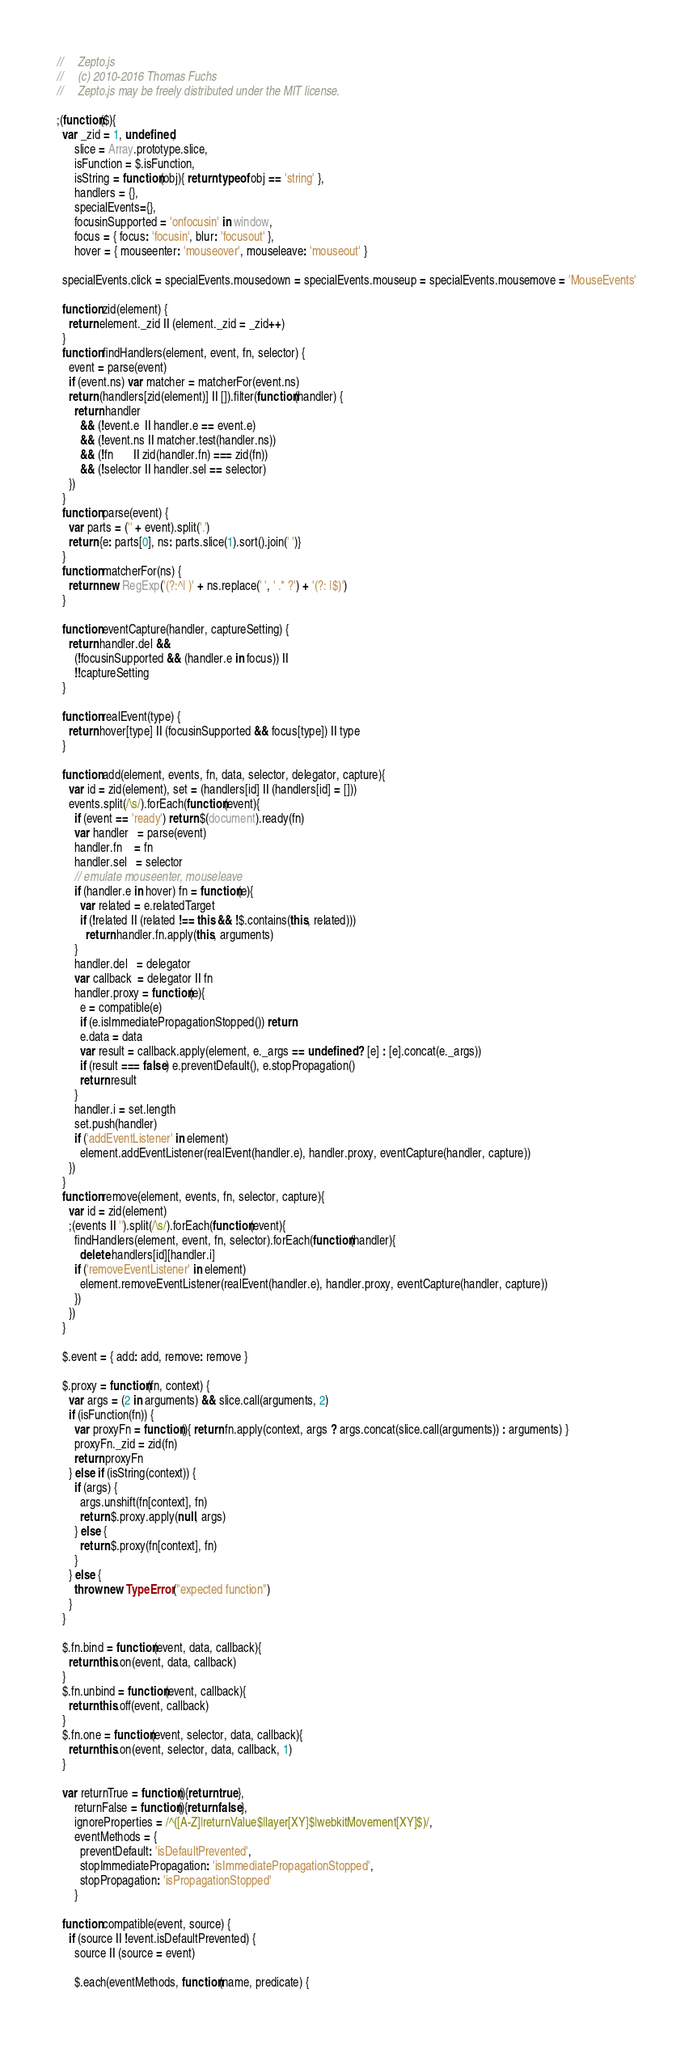Convert code to text. <code><loc_0><loc_0><loc_500><loc_500><_JavaScript_>//     Zepto.js
//     (c) 2010-2016 Thomas Fuchs
//     Zepto.js may be freely distributed under the MIT license.

;(function($){
  var _zid = 1, undefined,
      slice = Array.prototype.slice,
      isFunction = $.isFunction,
      isString = function(obj){ return typeof obj == 'string' },
      handlers = {},
      specialEvents={},
      focusinSupported = 'onfocusin' in window,
      focus = { focus: 'focusin', blur: 'focusout' },
      hover = { mouseenter: 'mouseover', mouseleave: 'mouseout' }

  specialEvents.click = specialEvents.mousedown = specialEvents.mouseup = specialEvents.mousemove = 'MouseEvents'

  function zid(element) {
    return element._zid || (element._zid = _zid++)
  }
  function findHandlers(element, event, fn, selector) {
    event = parse(event)
    if (event.ns) var matcher = matcherFor(event.ns)
    return (handlers[zid(element)] || []).filter(function(handler) {
      return handler
        && (!event.e  || handler.e == event.e)
        && (!event.ns || matcher.test(handler.ns))
        && (!fn       || zid(handler.fn) === zid(fn))
        && (!selector || handler.sel == selector)
    })
  }
  function parse(event) {
    var parts = ('' + event).split('.')
    return {e: parts[0], ns: parts.slice(1).sort().join(' ')}
  }
  function matcherFor(ns) {
    return new RegExp('(?:^| )' + ns.replace(' ', ' .* ?') + '(?: |$)')
  }

  function eventCapture(handler, captureSetting) {
    return handler.del &&
      (!focusinSupported && (handler.e in focus)) ||
      !!captureSetting
  }

  function realEvent(type) {
    return hover[type] || (focusinSupported && focus[type]) || type
  }

  function add(element, events, fn, data, selector, delegator, capture){
    var id = zid(element), set = (handlers[id] || (handlers[id] = []))
    events.split(/\s/).forEach(function(event){
      if (event == 'ready') return $(document).ready(fn)
      var handler   = parse(event)
      handler.fn    = fn
      handler.sel   = selector
      // emulate mouseenter, mouseleave
      if (handler.e in hover) fn = function(e){
        var related = e.relatedTarget
        if (!related || (related !== this && !$.contains(this, related)))
          return handler.fn.apply(this, arguments)
      }
      handler.del   = delegator
      var callback  = delegator || fn
      handler.proxy = function(e){
        e = compatible(e)
        if (e.isImmediatePropagationStopped()) return
        e.data = data
        var result = callback.apply(element, e._args == undefined ? [e] : [e].concat(e._args))
        if (result === false) e.preventDefault(), e.stopPropagation()
        return result
      }
      handler.i = set.length
      set.push(handler)
      if ('addEventListener' in element)
        element.addEventListener(realEvent(handler.e), handler.proxy, eventCapture(handler, capture))
    })
  }
  function remove(element, events, fn, selector, capture){
    var id = zid(element)
    ;(events || '').split(/\s/).forEach(function(event){
      findHandlers(element, event, fn, selector).forEach(function(handler){
        delete handlers[id][handler.i]
      if ('removeEventListener' in element)
        element.removeEventListener(realEvent(handler.e), handler.proxy, eventCapture(handler, capture))
      })
    })
  }

  $.event = { add: add, remove: remove }

  $.proxy = function(fn, context) {
    var args = (2 in arguments) && slice.call(arguments, 2)
    if (isFunction(fn)) {
      var proxyFn = function(){ return fn.apply(context, args ? args.concat(slice.call(arguments)) : arguments) }
      proxyFn._zid = zid(fn)
      return proxyFn
    } else if (isString(context)) {
      if (args) {
        args.unshift(fn[context], fn)
        return $.proxy.apply(null, args)
      } else {
        return $.proxy(fn[context], fn)
      }
    } else {
      throw new TypeError("expected function")
    }
  }

  $.fn.bind = function(event, data, callback){
    return this.on(event, data, callback)
  }
  $.fn.unbind = function(event, callback){
    return this.off(event, callback)
  }
  $.fn.one = function(event, selector, data, callback){
    return this.on(event, selector, data, callback, 1)
  }

  var returnTrue = function(){return true},
      returnFalse = function(){return false},
      ignoreProperties = /^([A-Z]|returnValue$|layer[XY]$|webkitMovement[XY]$)/,
      eventMethods = {
        preventDefault: 'isDefaultPrevented',
        stopImmediatePropagation: 'isImmediatePropagationStopped',
        stopPropagation: 'isPropagationStopped'
      }

  function compatible(event, source) {
    if (source || !event.isDefaultPrevented) {
      source || (source = event)

      $.each(eventMethods, function(name, predicate) {</code> 